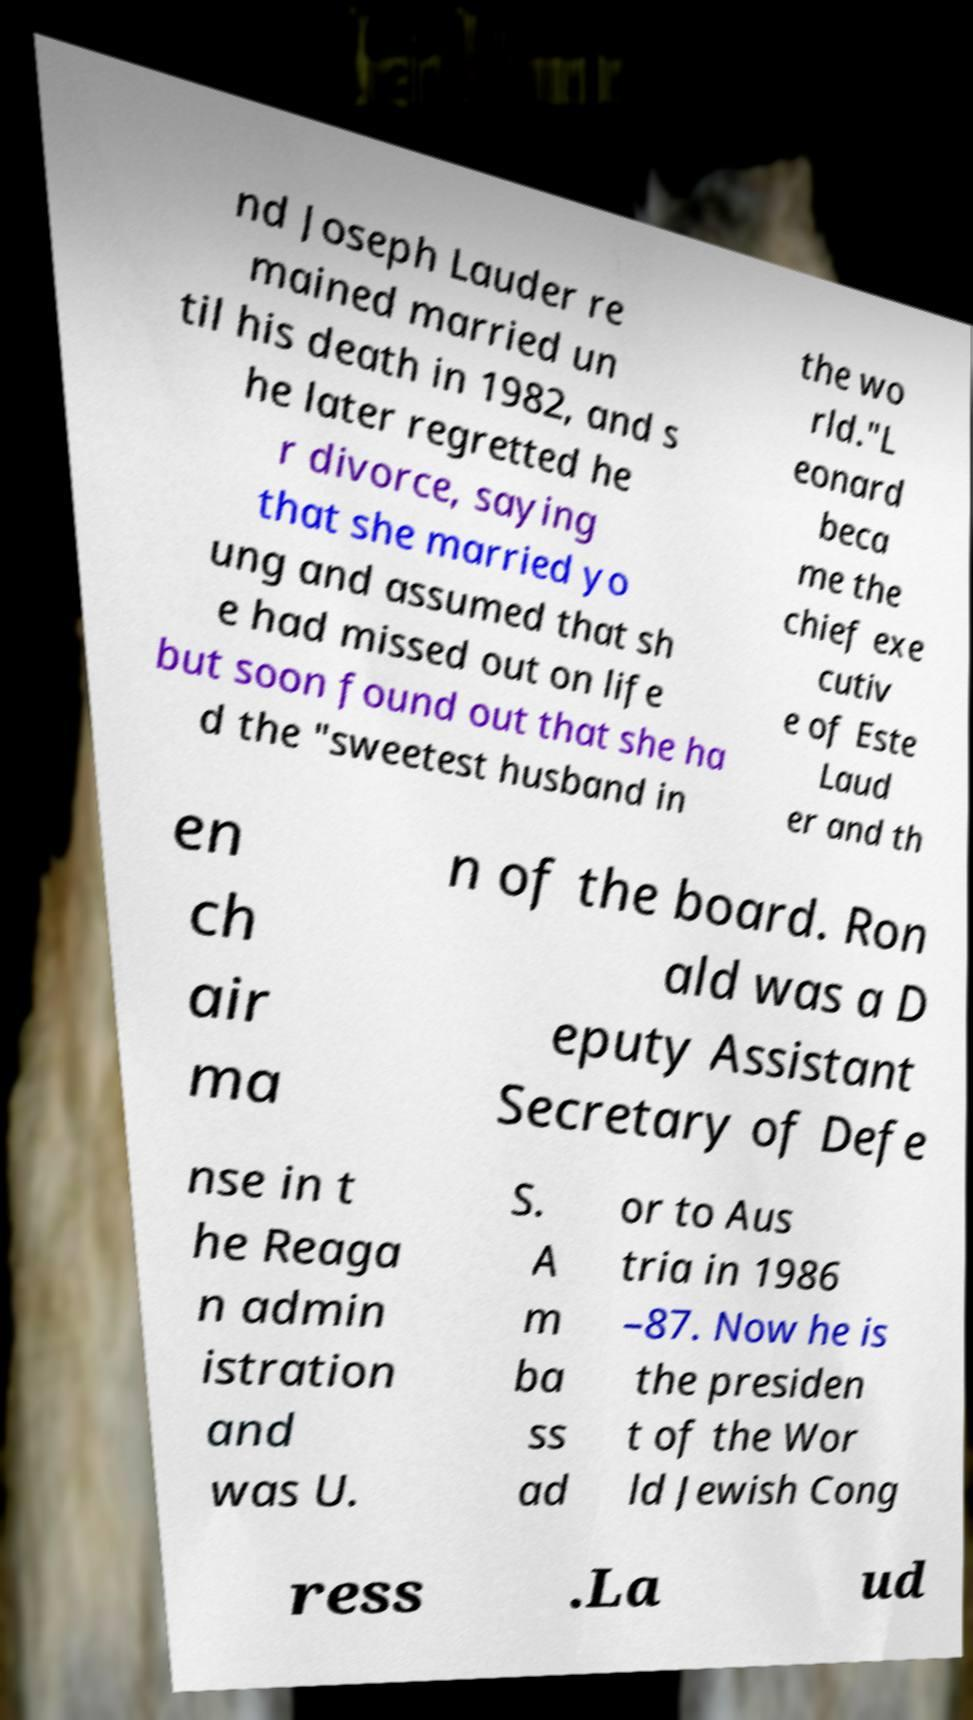What messages or text are displayed in this image? I need them in a readable, typed format. nd Joseph Lauder re mained married un til his death in 1982, and s he later regretted he r divorce, saying that she married yo ung and assumed that sh e had missed out on life but soon found out that she ha d the "sweetest husband in the wo rld."L eonard beca me the chief exe cutiv e of Este Laud er and th en ch air ma n of the board. Ron ald was a D eputy Assistant Secretary of Defe nse in t he Reaga n admin istration and was U. S. A m ba ss ad or to Aus tria in 1986 –87. Now he is the presiden t of the Wor ld Jewish Cong ress .La ud 